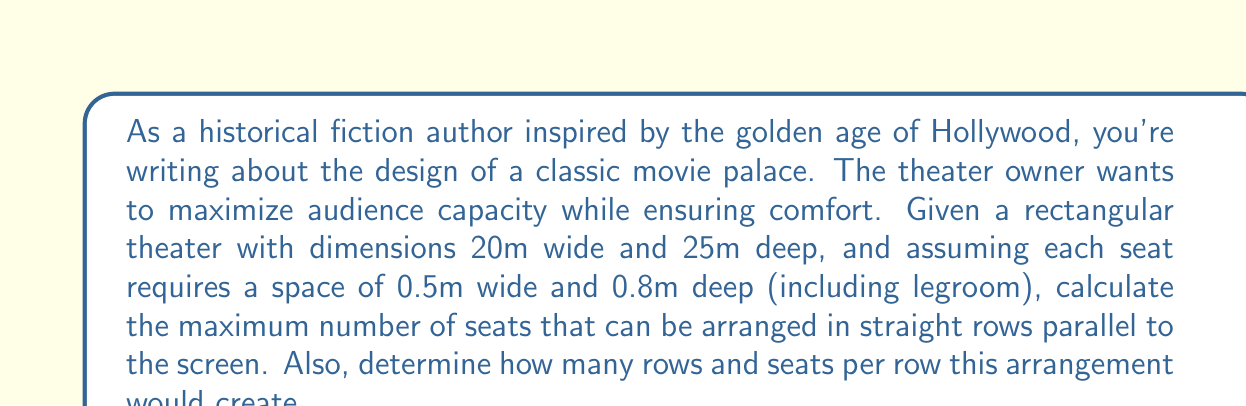What is the answer to this math problem? Let's approach this step-by-step:

1. Calculate the number of seats that can fit in a row:
   - Theater width = 20m
   - Seat width = 0.5m
   - Number of seats per row = $\left\lfloor\frac{20}{0.5}\right\rfloor = 40$ seats
   (We use the floor function to ensure we have a whole number of seats)

2. Calculate the number of rows that can fit in the theater:
   - Theater depth = 25m
   - Seat depth (including legroom) = 0.8m
   - Number of rows = $\left\lfloor\frac{25}{0.8}\right\rfloor = 31$ rows

3. Calculate the total number of seats:
   - Total seats = Number of seats per row × Number of rows
   - Total seats = $40 \times 31 = 1240$ seats

Therefore, the optimal seating arrangement to maximize capacity would be 31 rows with 40 seats in each row, totaling 1240 seats.

This arrangement assumes:
- All seats are the same size
- There are no aisles or spaces between seats
- The entire theater space is used for seating (no stage or screen area)

In reality, building codes and comfort considerations would likely reduce this number, but this calculation provides the theoretical maximum for the given dimensions.
Answer: 1240 seats; 31 rows of 40 seats each 